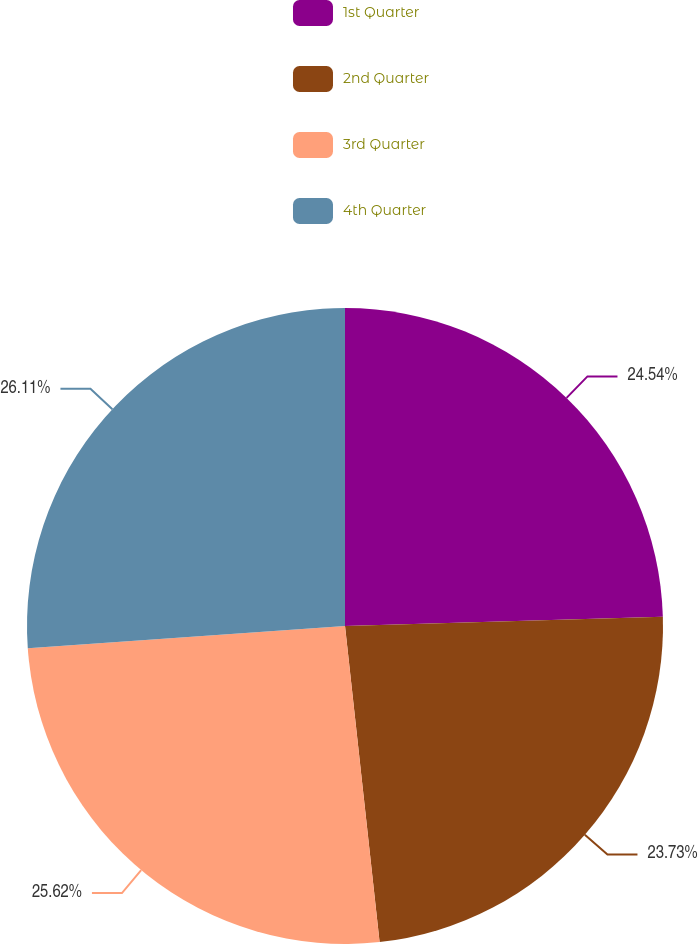<chart> <loc_0><loc_0><loc_500><loc_500><pie_chart><fcel>1st Quarter<fcel>2nd Quarter<fcel>3rd Quarter<fcel>4th Quarter<nl><fcel>24.54%<fcel>23.73%<fcel>25.62%<fcel>26.12%<nl></chart> 